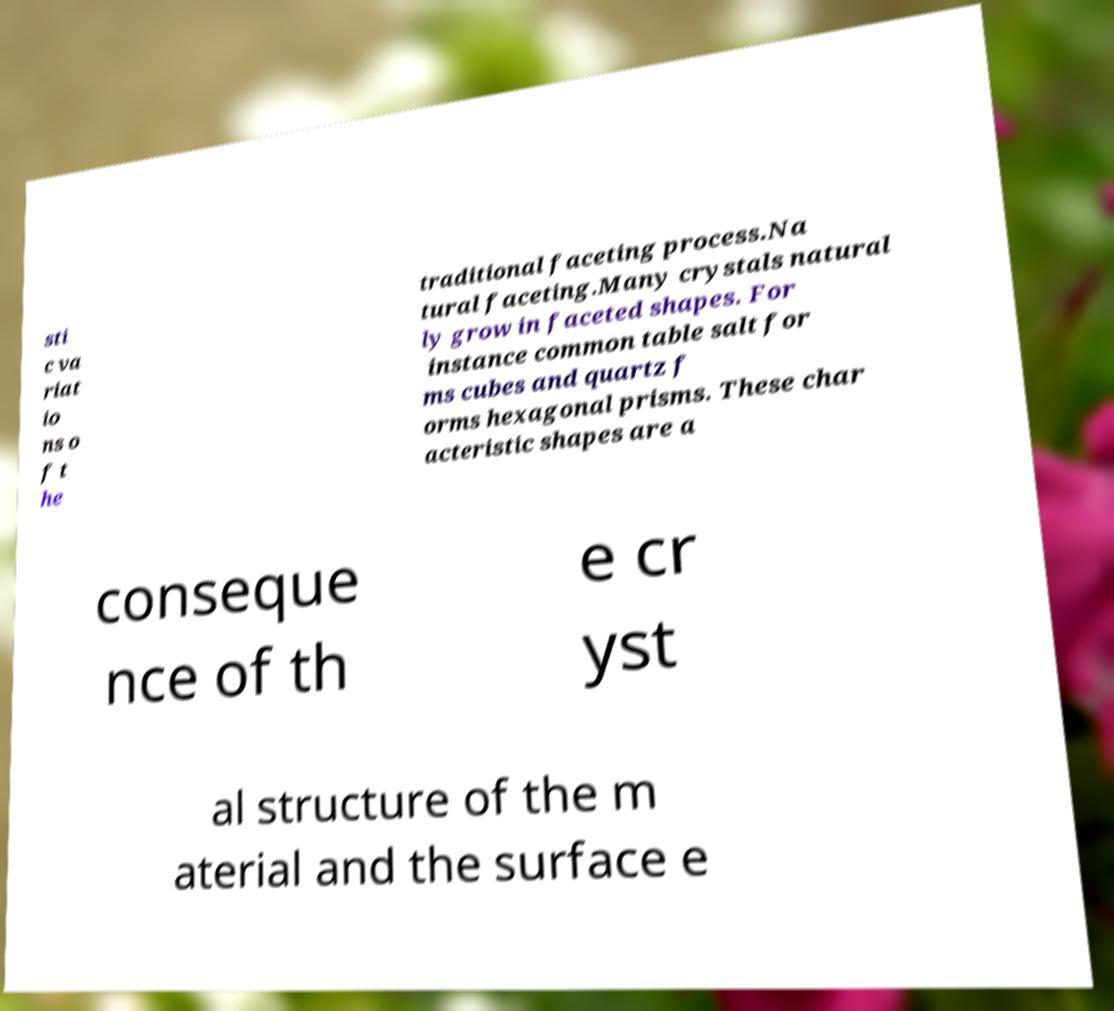Could you assist in decoding the text presented in this image and type it out clearly? sti c va riat io ns o f t he traditional faceting process.Na tural faceting.Many crystals natural ly grow in faceted shapes. For instance common table salt for ms cubes and quartz f orms hexagonal prisms. These char acteristic shapes are a conseque nce of th e cr yst al structure of the m aterial and the surface e 